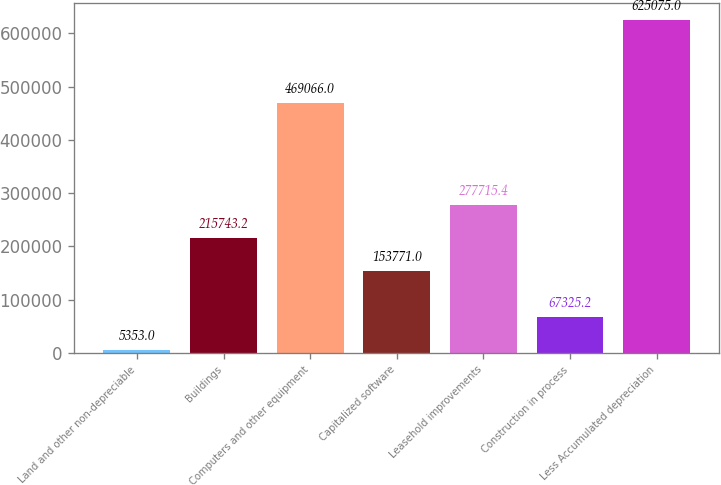<chart> <loc_0><loc_0><loc_500><loc_500><bar_chart><fcel>Land and other non-depreciable<fcel>Buildings<fcel>Computers and other equipment<fcel>Capitalized software<fcel>Leasehold improvements<fcel>Construction in process<fcel>Less Accumulated depreciation<nl><fcel>5353<fcel>215743<fcel>469066<fcel>153771<fcel>277715<fcel>67325.2<fcel>625075<nl></chart> 